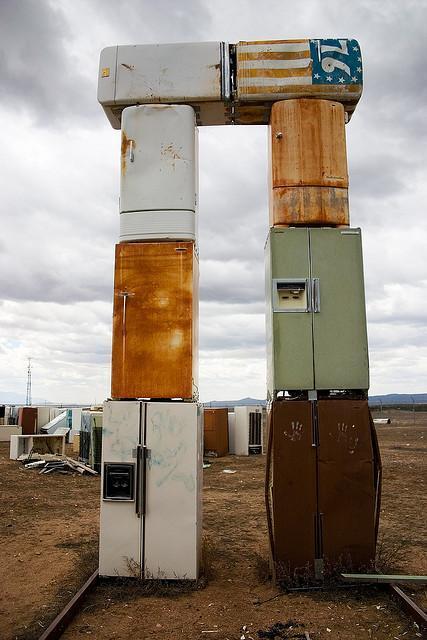How many refrigerators can be seen?
Give a very brief answer. 8. 